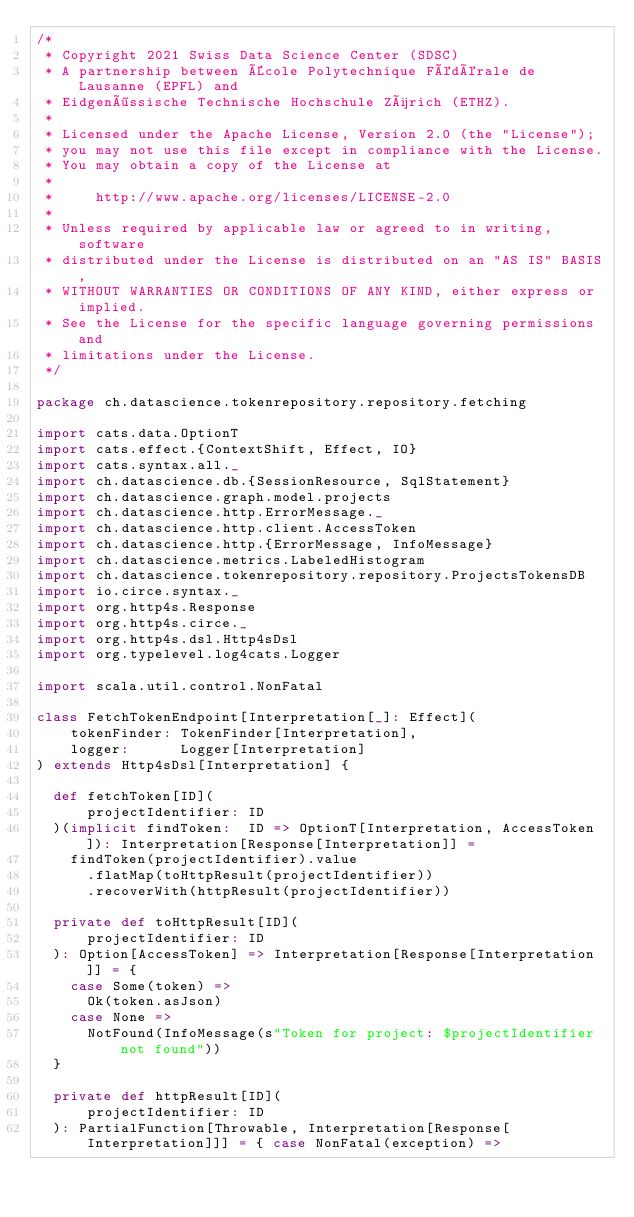<code> <loc_0><loc_0><loc_500><loc_500><_Scala_>/*
 * Copyright 2021 Swiss Data Science Center (SDSC)
 * A partnership between École Polytechnique Fédérale de Lausanne (EPFL) and
 * Eidgenössische Technische Hochschule Zürich (ETHZ).
 *
 * Licensed under the Apache License, Version 2.0 (the "License");
 * you may not use this file except in compliance with the License.
 * You may obtain a copy of the License at
 *
 *     http://www.apache.org/licenses/LICENSE-2.0
 *
 * Unless required by applicable law or agreed to in writing, software
 * distributed under the License is distributed on an "AS IS" BASIS,
 * WITHOUT WARRANTIES OR CONDITIONS OF ANY KIND, either express or implied.
 * See the License for the specific language governing permissions and
 * limitations under the License.
 */

package ch.datascience.tokenrepository.repository.fetching

import cats.data.OptionT
import cats.effect.{ContextShift, Effect, IO}
import cats.syntax.all._
import ch.datascience.db.{SessionResource, SqlStatement}
import ch.datascience.graph.model.projects
import ch.datascience.http.ErrorMessage._
import ch.datascience.http.client.AccessToken
import ch.datascience.http.{ErrorMessage, InfoMessage}
import ch.datascience.metrics.LabeledHistogram
import ch.datascience.tokenrepository.repository.ProjectsTokensDB
import io.circe.syntax._
import org.http4s.Response
import org.http4s.circe._
import org.http4s.dsl.Http4sDsl
import org.typelevel.log4cats.Logger

import scala.util.control.NonFatal

class FetchTokenEndpoint[Interpretation[_]: Effect](
    tokenFinder: TokenFinder[Interpretation],
    logger:      Logger[Interpretation]
) extends Http4sDsl[Interpretation] {

  def fetchToken[ID](
      projectIdentifier: ID
  )(implicit findToken:  ID => OptionT[Interpretation, AccessToken]): Interpretation[Response[Interpretation]] =
    findToken(projectIdentifier).value
      .flatMap(toHttpResult(projectIdentifier))
      .recoverWith(httpResult(projectIdentifier))

  private def toHttpResult[ID](
      projectIdentifier: ID
  ): Option[AccessToken] => Interpretation[Response[Interpretation]] = {
    case Some(token) =>
      Ok(token.asJson)
    case None =>
      NotFound(InfoMessage(s"Token for project: $projectIdentifier not found"))
  }

  private def httpResult[ID](
      projectIdentifier: ID
  ): PartialFunction[Throwable, Interpretation[Response[Interpretation]]] = { case NonFatal(exception) =></code> 